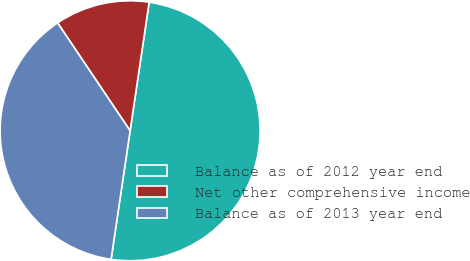<chart> <loc_0><loc_0><loc_500><loc_500><pie_chart><fcel>Balance as of 2012 year end<fcel>Net other comprehensive income<fcel>Balance as of 2013 year end<nl><fcel>50.0%<fcel>11.76%<fcel>38.24%<nl></chart> 